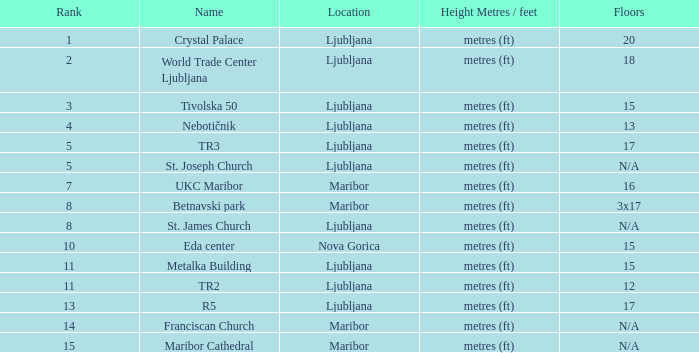Which Floors have a Location of ljubljana, and a Name of tr3? 17.0. 